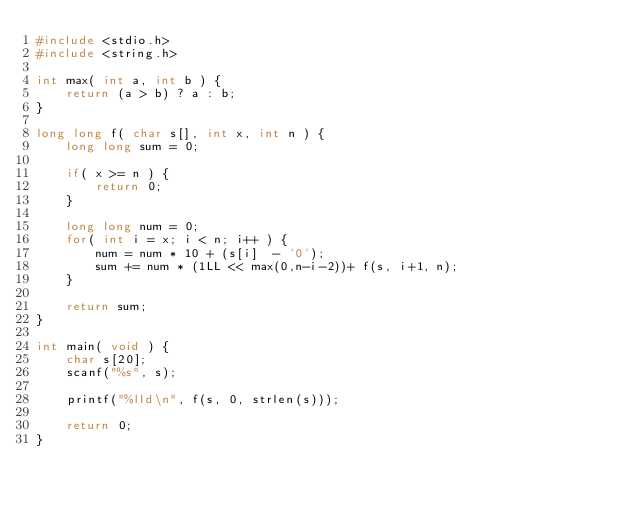Convert code to text. <code><loc_0><loc_0><loc_500><loc_500><_C++_>#include <stdio.h>
#include <string.h>

int max( int a, int b ) {
	return (a > b) ? a : b;
}

long long f( char s[], int x, int n ) {
	long long sum = 0;
	
	if( x >= n ) {
		return 0;
	}
		
	long long num = 0;
	for( int i = x; i < n; i++ ) {
		num = num * 10 + (s[i]  - '0');
		sum += num * (1LL << max(0,n-i-2))+ f(s, i+1, n);
	}
	
	return sum;
}

int main( void ) {
	char s[20];
	scanf("%s", s);
	
	printf("%lld\n", f(s, 0, strlen(s)));
	
	return 0;
}</code> 